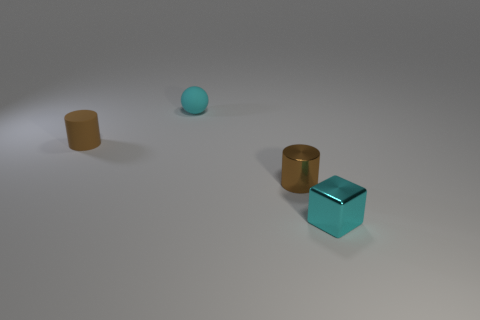Add 1 tiny brown metal cylinders. How many objects exist? 5 Subtract all spheres. How many objects are left? 3 Add 2 tiny brown cylinders. How many tiny brown cylinders are left? 4 Add 3 cyan matte things. How many cyan matte things exist? 4 Subtract 0 gray cubes. How many objects are left? 4 Subtract all green cylinders. Subtract all red balls. How many cylinders are left? 2 Subtract all gray balls. How many purple cylinders are left? 0 Subtract all small gray blocks. Subtract all tiny shiny things. How many objects are left? 2 